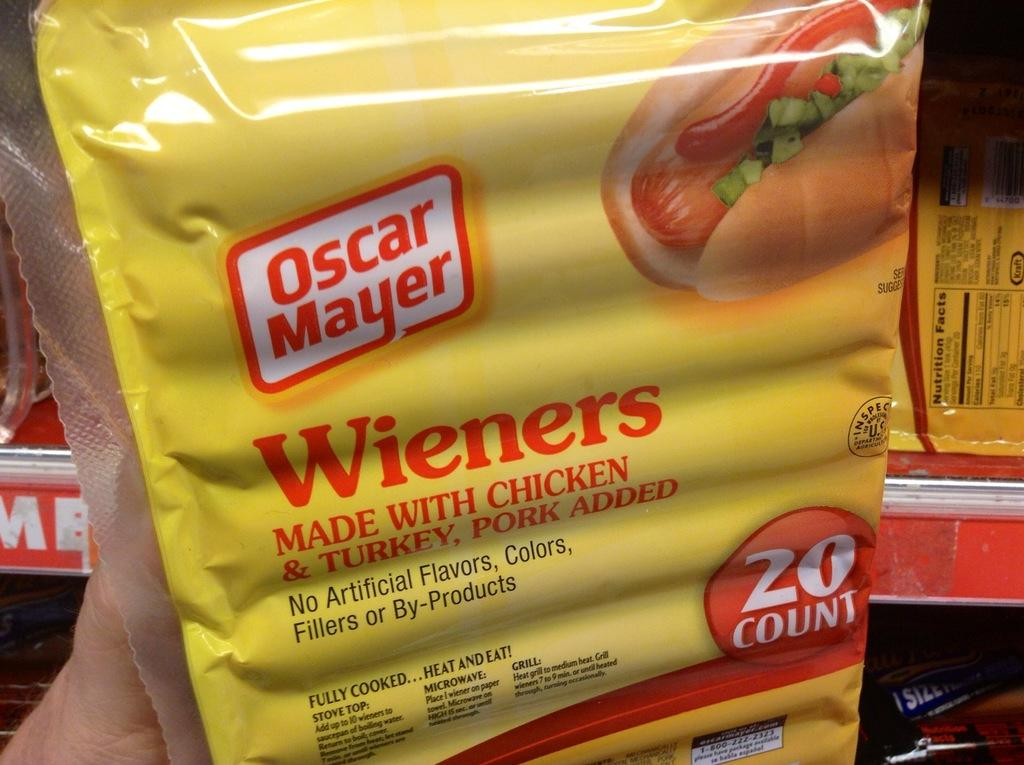What is the person holding in the image? There is a packet in a person's hand in the image. What can be seen in the background of the image? There are objects arranged in shelves in the background of the image. What type of territory is being claimed by the person in the image? There is no indication of territory being claimed in the image; the person is simply holding a packet. 